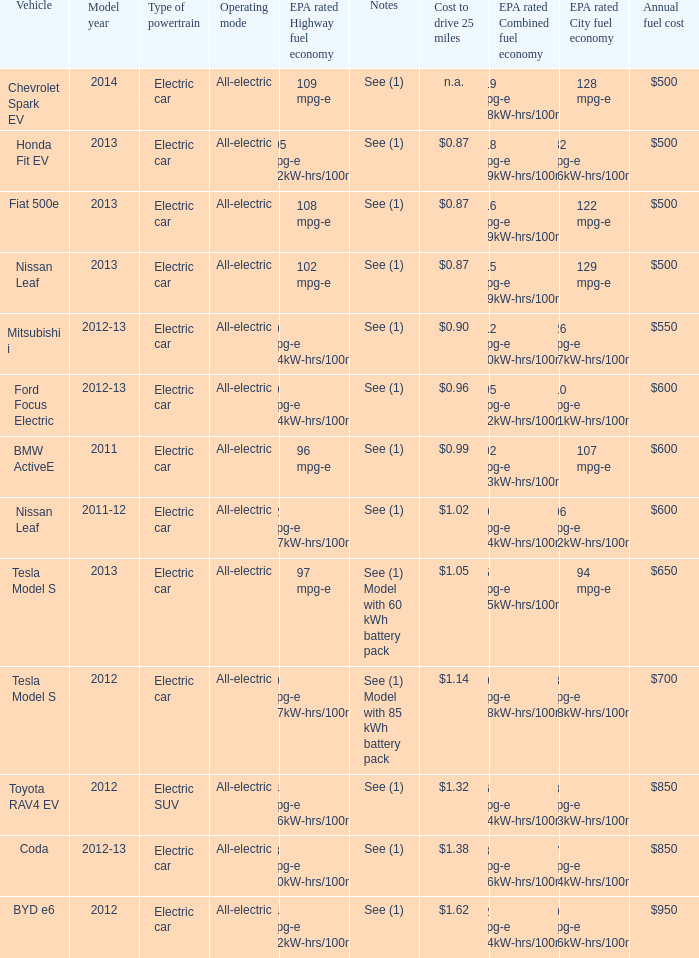What vehicle has an epa highway fuel economy of 109 mpg-e? Chevrolet Spark EV. 